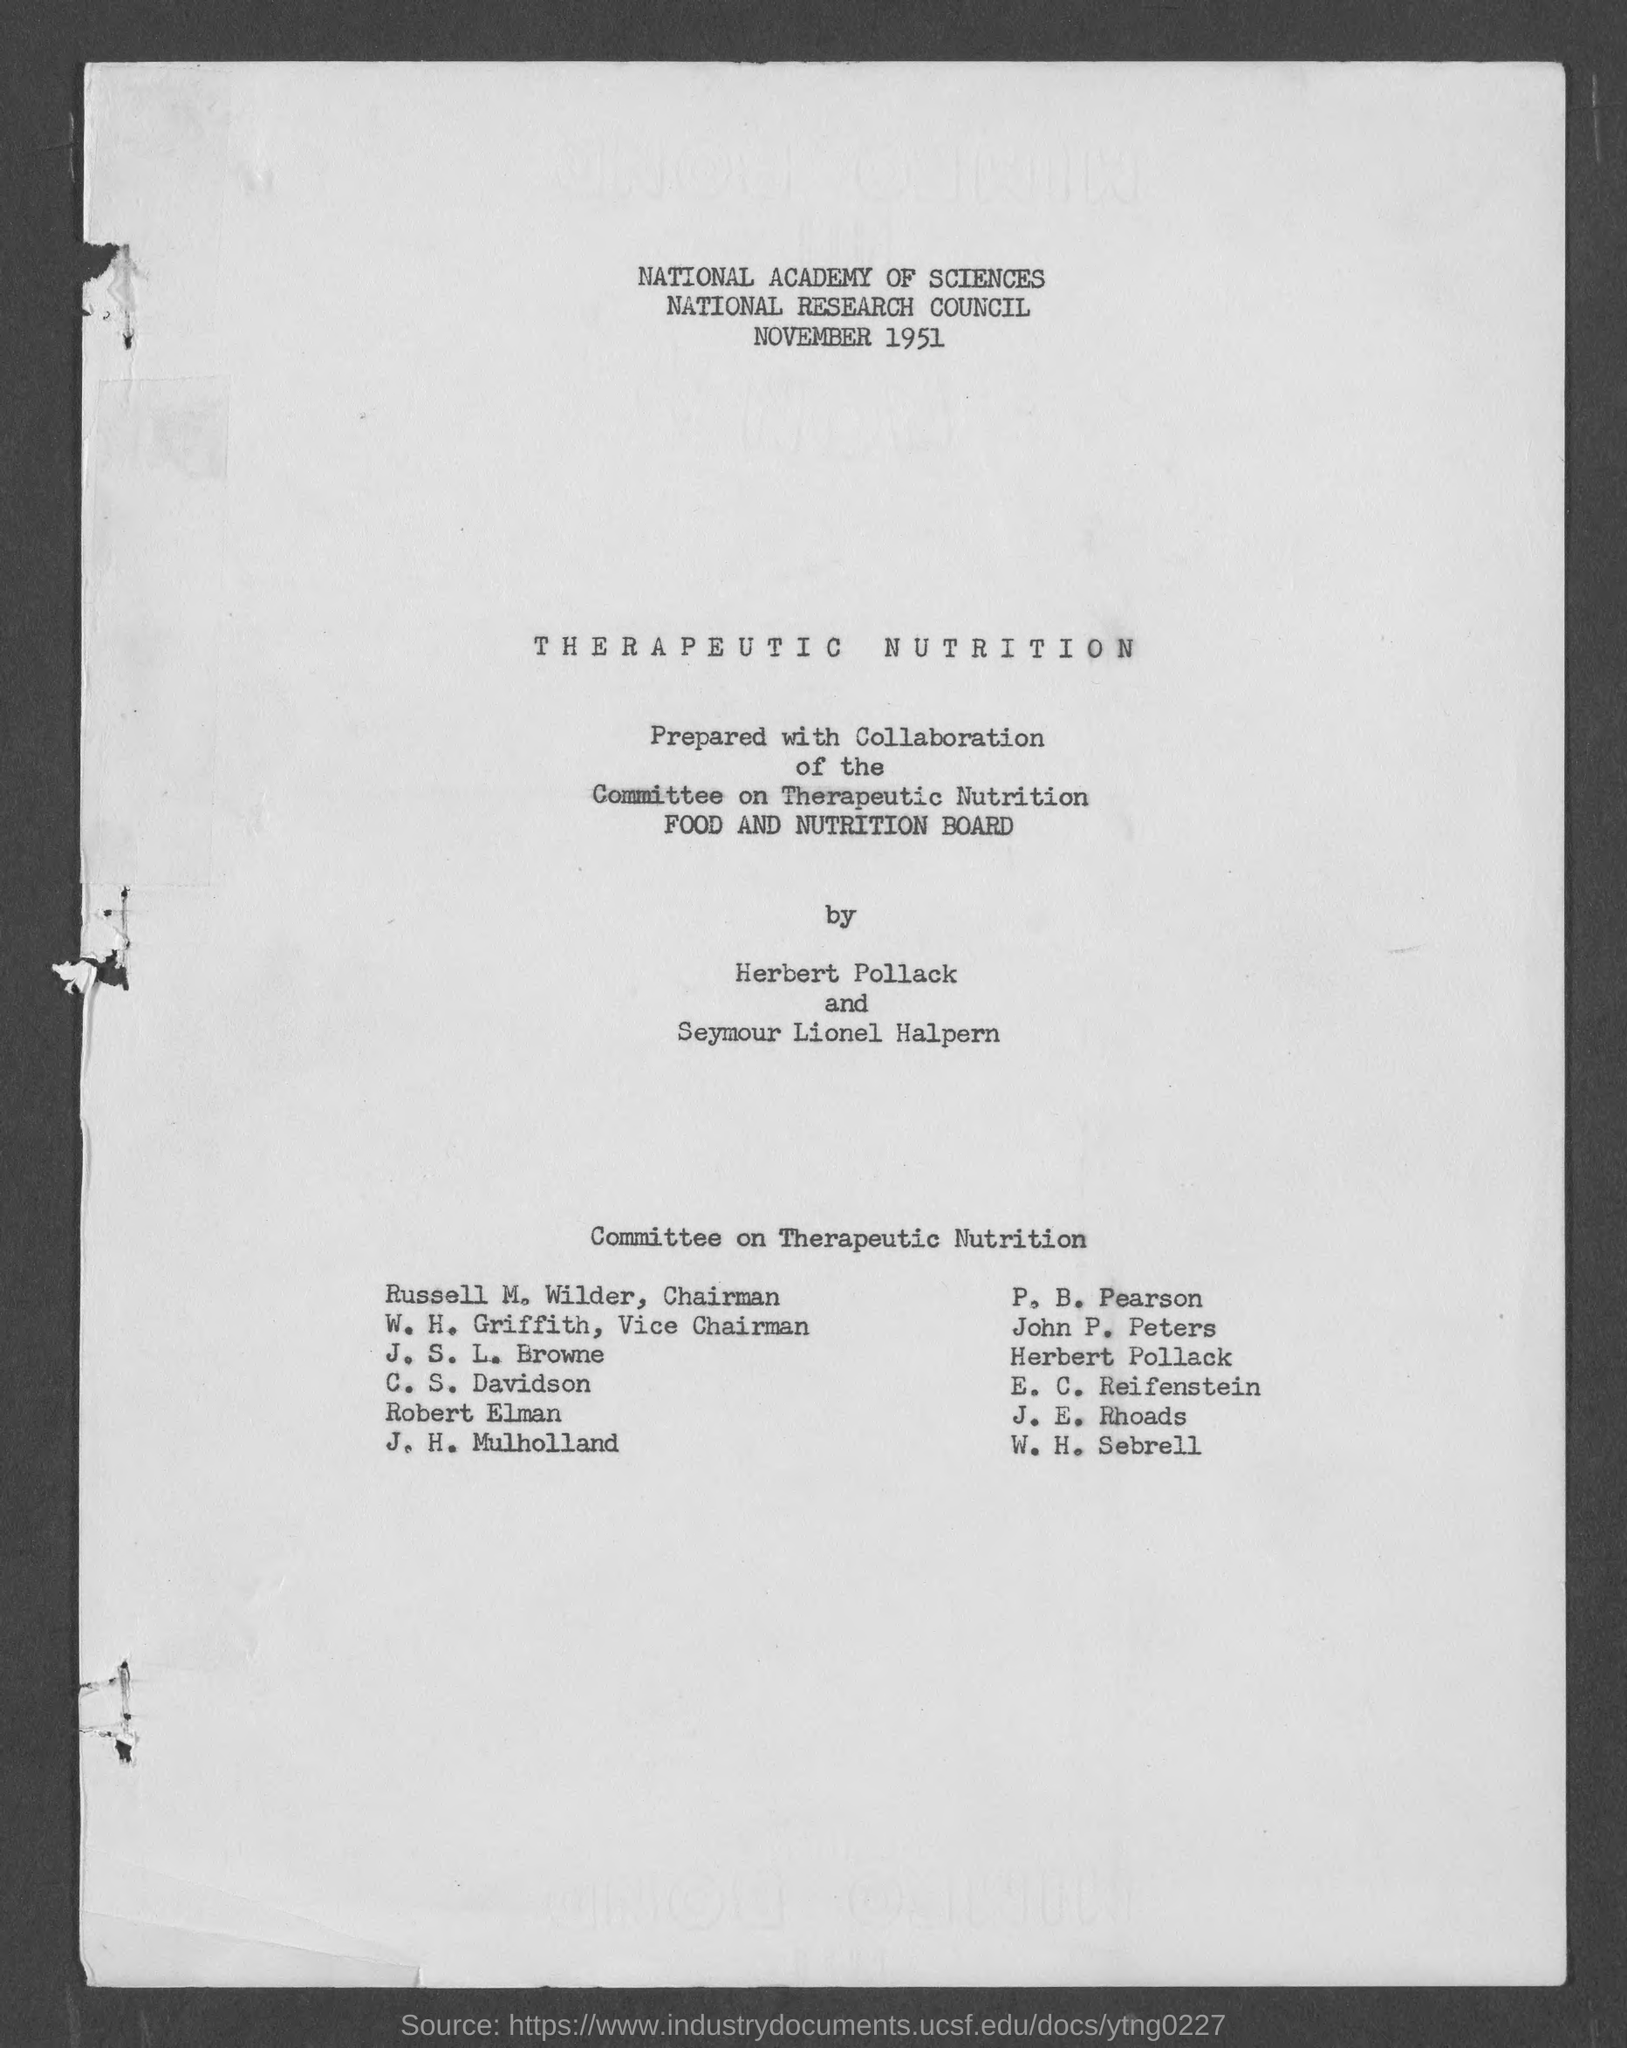Highlight a few significant elements in this photo. The Chairman of the Committee on Therapeutic Nutrition is Russell M. Wilder. 